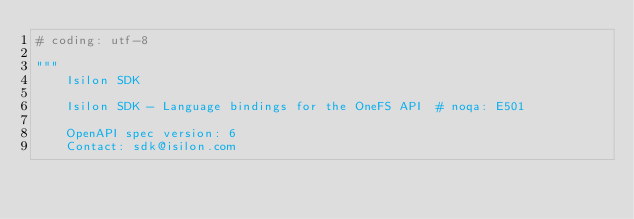<code> <loc_0><loc_0><loc_500><loc_500><_Python_># coding: utf-8

"""
    Isilon SDK

    Isilon SDK - Language bindings for the OneFS API  # noqa: E501

    OpenAPI spec version: 6
    Contact: sdk@isilon.com</code> 